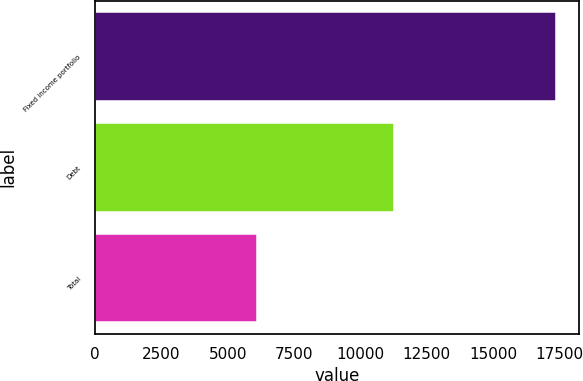Convert chart to OTSL. <chart><loc_0><loc_0><loc_500><loc_500><bar_chart><fcel>Fixed income portfolio<fcel>Debt<fcel>Total<nl><fcel>17375<fcel>11281<fcel>6094<nl></chart> 